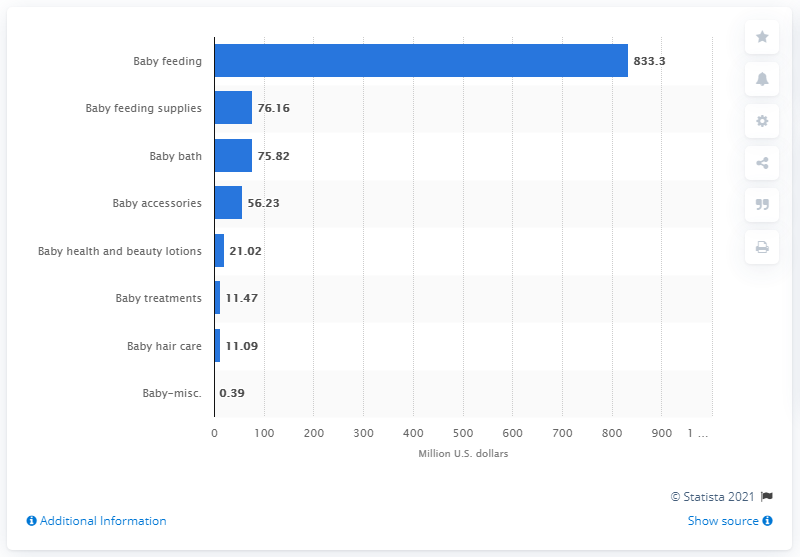Give some essential details in this illustration. In 2018, the sales of baby bath products in the United States amounted to 76.16 million units. 